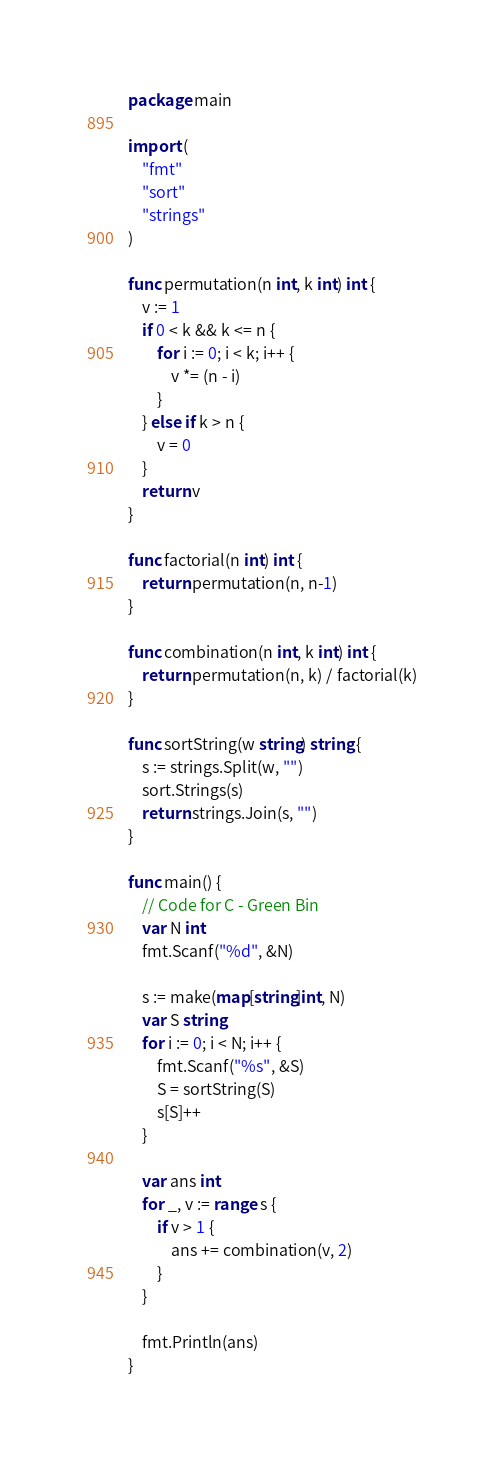<code> <loc_0><loc_0><loc_500><loc_500><_Go_>package main

import (
	"fmt"
	"sort"
	"strings"
)

func permutation(n int, k int) int {
	v := 1
	if 0 < k && k <= n {
		for i := 0; i < k; i++ {
			v *= (n - i)
		}
	} else if k > n {
		v = 0
	}
	return v
}

func factorial(n int) int {
	return permutation(n, n-1)
}

func combination(n int, k int) int {
	return permutation(n, k) / factorial(k)
}

func sortString(w string) string {
	s := strings.Split(w, "")
	sort.Strings(s)
	return strings.Join(s, "")
}

func main() {
	// Code for C - Green Bin
	var N int
	fmt.Scanf("%d", &N)

	s := make(map[string]int, N)
	var S string
	for i := 0; i < N; i++ {
		fmt.Scanf("%s", &S)
		S = sortString(S)
		s[S]++
	}

	var ans int
	for _, v := range s {
		if v > 1 {
			ans += combination(v, 2)
		}
	}

	fmt.Println(ans)
}
</code> 